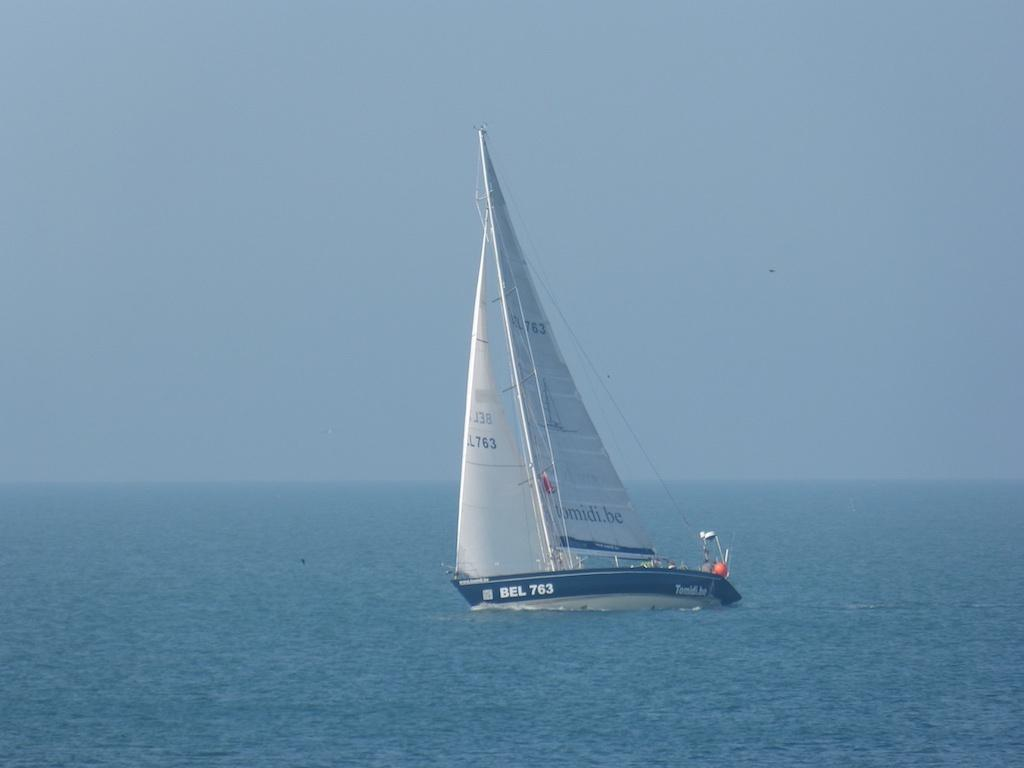What is the main subject in the center of the image? There is a boat in the center of the image. Where is the boat located? The boat is on the water. What can be seen in the background of the image? There is sky visible in the background of the image. What type of copper material can be seen in the boat's hall in the image? There is no copper material or hall present in the boat in the image. 